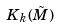<formula> <loc_0><loc_0><loc_500><loc_500>K _ { k } ( \tilde { M } )</formula> 